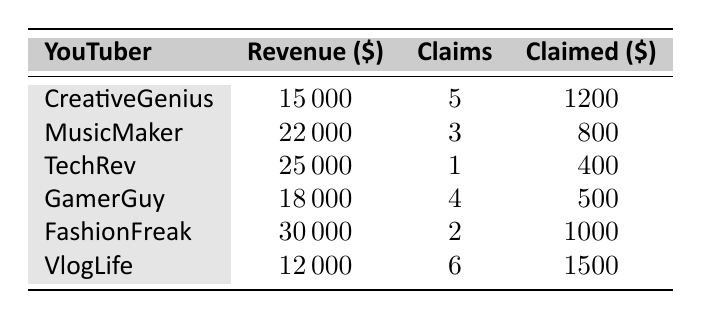What is the total revenue generated by all YouTubers? To find the total revenue, we sum the revenue of all YouTubers: 15000 + 22000 + 25000 + 18000 + 30000 + 12000 = 122000.
Answer: 122000 Which YouTuber has the highest revenue? By comparing the revenue values, TechRev has the highest at 25000.
Answer: TechRev What is the average claimed amount among all YouTubers? Adding up the claimed amounts gives 1200 + 800 + 400 + 500 + 1000 + 1500 = 4400. There are 6 YouTubers, so the average is 4400 / 6 = 733.33.
Answer: 733.33 Is the claimed amount for MusicMaker greater than that of FashionFreak? MusicMaker's claimed amount is 800 and FashionFreak's is 1000. Since 800 is not greater than 1000, the statement is false.
Answer: No How many YouTubers have more than 4 copyright claims? The YouTubers with more than 4 claims are CreativeGenius (5 claims) and VlogLife (6 claims), which totals to 2 YouTubers.
Answer: 2 What is the difference in claimed amounts between VlogLife and TechRev? VlogLife's claimed amount is 1500 and TechRev's is 400. The difference is 1500 - 400 = 1100.
Answer: 1100 Does any YouTuber have zero copyright claims? Looking at the claims, the minimum is 1 (for TechRev), so no YouTuber has zero copyright claims.
Answer: No Which YouTuber has the fewest copyright claims, and how many do they have? Checking the copyright claims, TechRev has the fewest at only 1 claim.
Answer: TechRev, 1 claim 